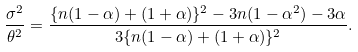Convert formula to latex. <formula><loc_0><loc_0><loc_500><loc_500>\frac { \sigma ^ { 2 } } { \theta ^ { 2 } } = \frac { \{ n ( 1 - \alpha ) + ( 1 + \alpha ) \} ^ { 2 } - 3 n ( 1 - \alpha ^ { 2 } ) - 3 \alpha } { 3 \{ n ( 1 - \alpha ) + ( 1 + \alpha ) \} ^ { 2 } } .</formula> 